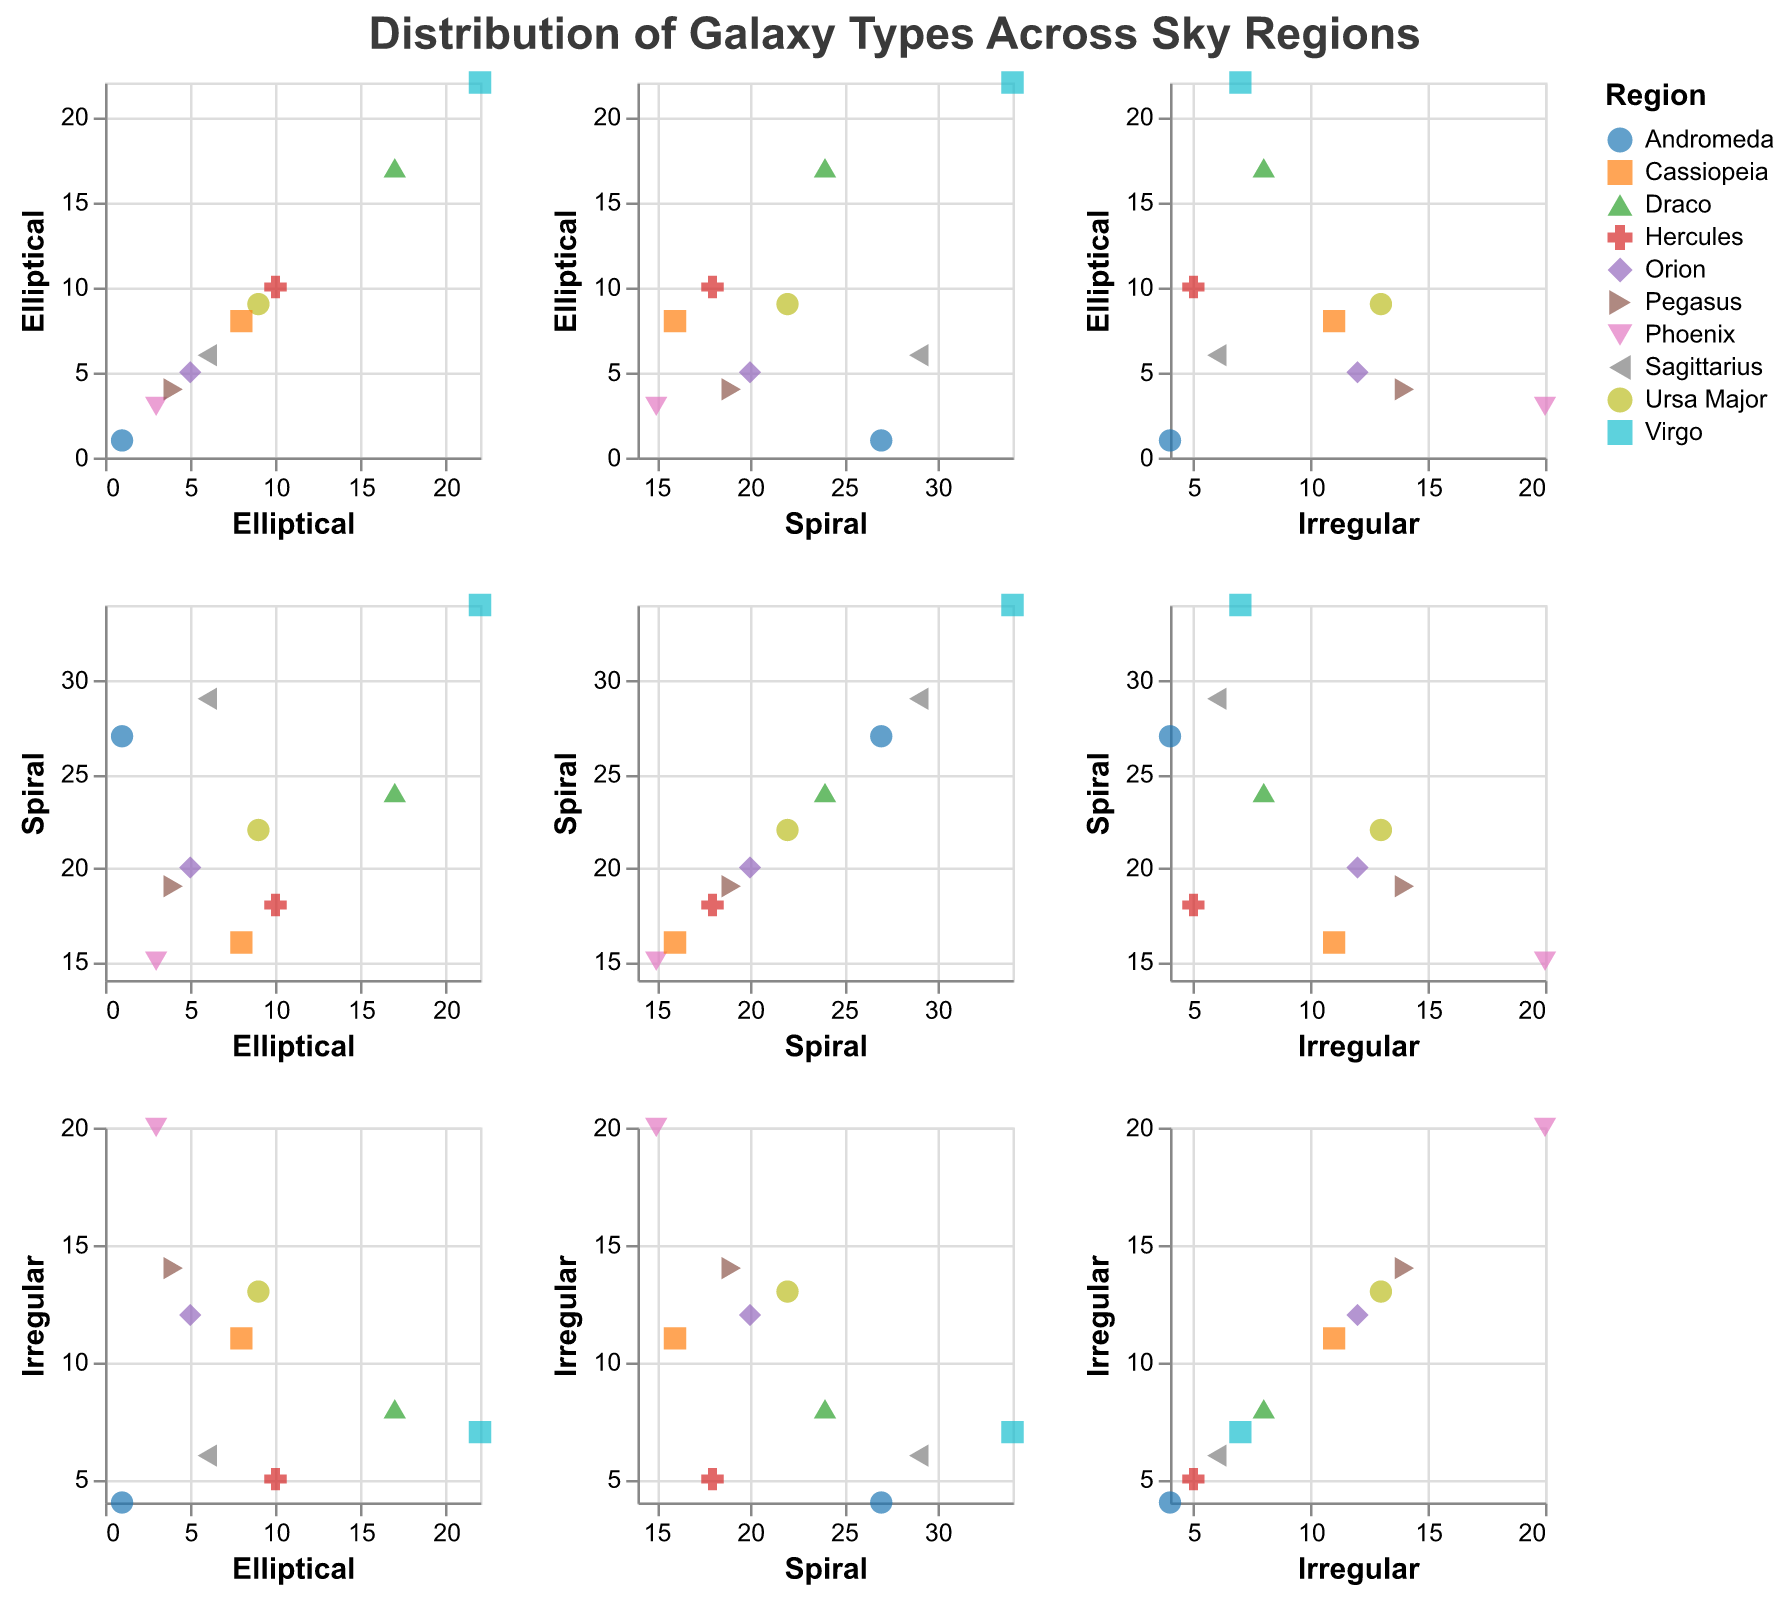What's the title of the graph? The title is located at the top of the figure, and the text is displayed in a bold font.
Answer: Distribution of Galaxy Types Across Sky Regions Which region has the highest number of Spiral galaxies? By checking the scatter plot column for Spiral galaxies, look at the tooltip or the data points. The highest count in the Spiral axis is from Virgo.
Answer: Virgo Which region has the lowest number of Elliptical galaxies? Look at the scatter plot column for Elliptical galaxies. The region with the lowest count corresponds to the lowest position on the Elliptical axis, which is Andromeda.
Answer: Andromeda What is the total count of Elliptical galaxies in Draco and Ursa Major? Identify the points for Draco and Ursa Major in the column corresponding to Elliptical galaxies. Add the counts: 17 (Draco) + 9 (Ursa Major).
Answer: 26 Is there any region where the number of Irregular galaxies is greater than the number of Elliptical galaxies? Compare the data points in each region for Irregular and Elliptical galaxies. Check if Irregular is higher than Elliptical. Phoenix has 20 Irregular and 3 Elliptical.
Answer: Yes, Phoenix Between Spiral and Irregular galaxies, which type shows more variation across regions? Compare the spread of data points for Spiral and Irregular columns. The Spiral galaxies have a wider range from 15 to 34, whereas Irregular ranges from 4 to 20.
Answer: Spiral galaxies Which region has a comparable number of Spiral and Elliptical galaxies? Compare the data points in the regions for Spiral and Elliptical columns. Draco and Cassiopeia have somewhat close counts.
Answer: Draco What is the average number of Irregular galaxies across all regions? Sum all the Irregular galaxy counts (12 + 7 + 5 + 20 + 4 + 13 + 14 + 8 + 6 + 11) and divide by the number of regions (10). (12 + 7 + 5 + 20 + 4 + 13 + 14 + 8 + 6 + 11) / 10 = 10
Answer: 10 Which region shows a higher number of Spiral galaxies compared to Irregular galaxies but fewer than Elliptical galaxies? Compare the data points for all regions where Spiral is higher than Irregular but lower than Elliptical. Virgo satisfies this condition with more Spirals than Irregular and fewer than Elliptical.
Answer: Virgo In which region are the counts of all galaxy types within 10 of each other? Compare the data points for each region ensuring the differences in counts for Elliptical, Spiral, and Irregular are all within 10 units. Ursa Major has 9 Elliptical, 22 Spiral, and 13 Irregular, all within a span of 10.
Answer: Ursa Major 